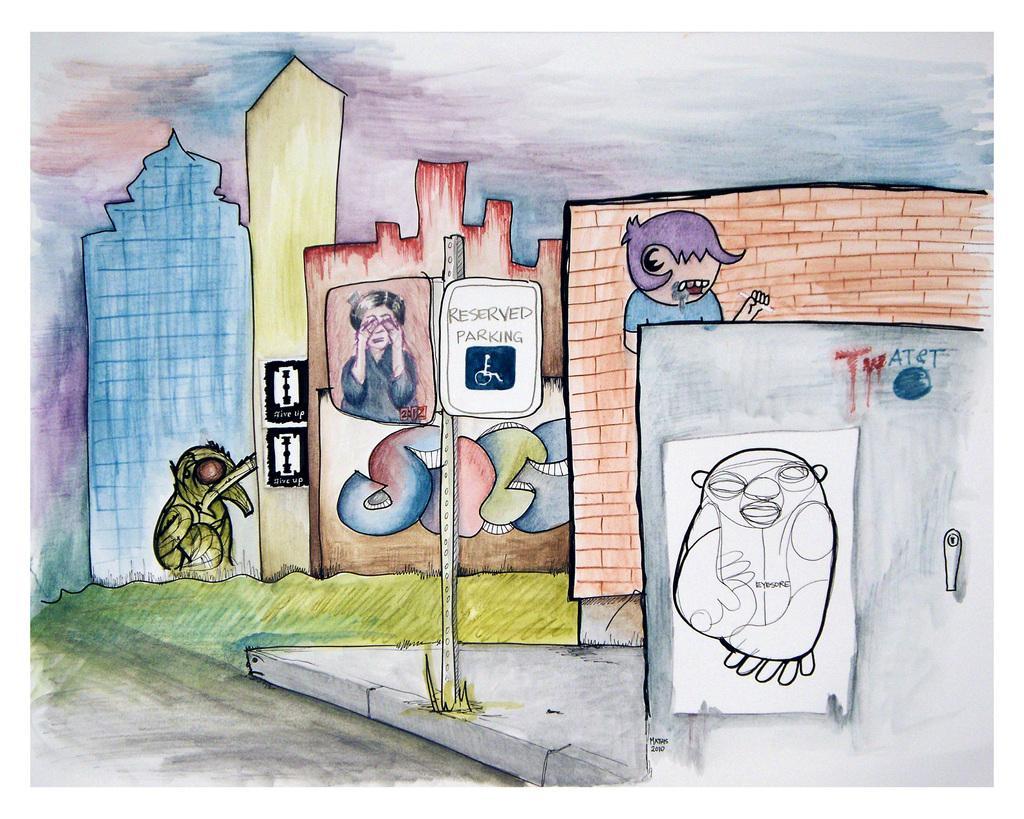How would you summarize this image in a sentence or two? This is a picture of a painting. In this picture we can see a board, people, walls. On the right side we can see the drawing sketch and there is something written. 